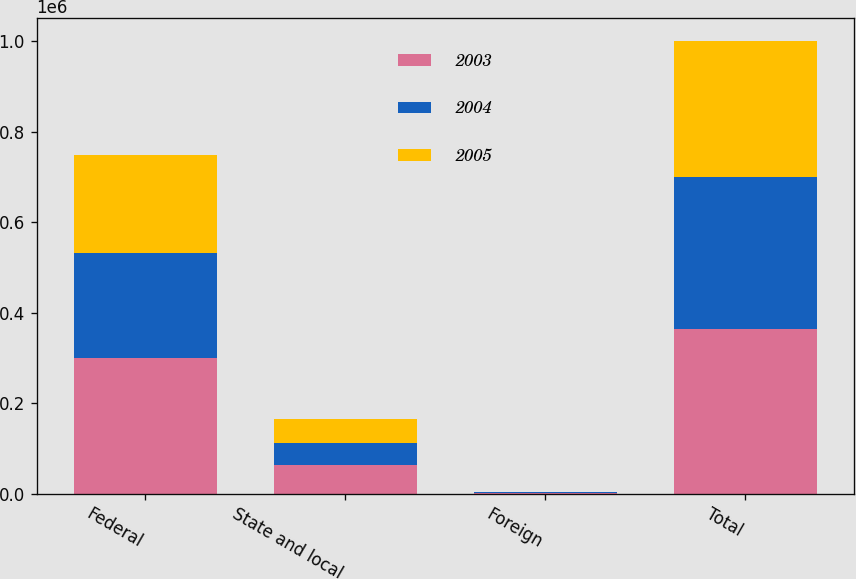<chart> <loc_0><loc_0><loc_500><loc_500><stacked_bar_chart><ecel><fcel>Federal<fcel>State and local<fcel>Foreign<fcel>Total<nl><fcel>2003<fcel>298991<fcel>62232<fcel>2293<fcel>364177<nl><fcel>2004<fcel>233635<fcel>50527<fcel>682<fcel>335931<nl><fcel>2005<fcel>214729<fcel>51771<fcel>728<fcel>301081<nl></chart> 